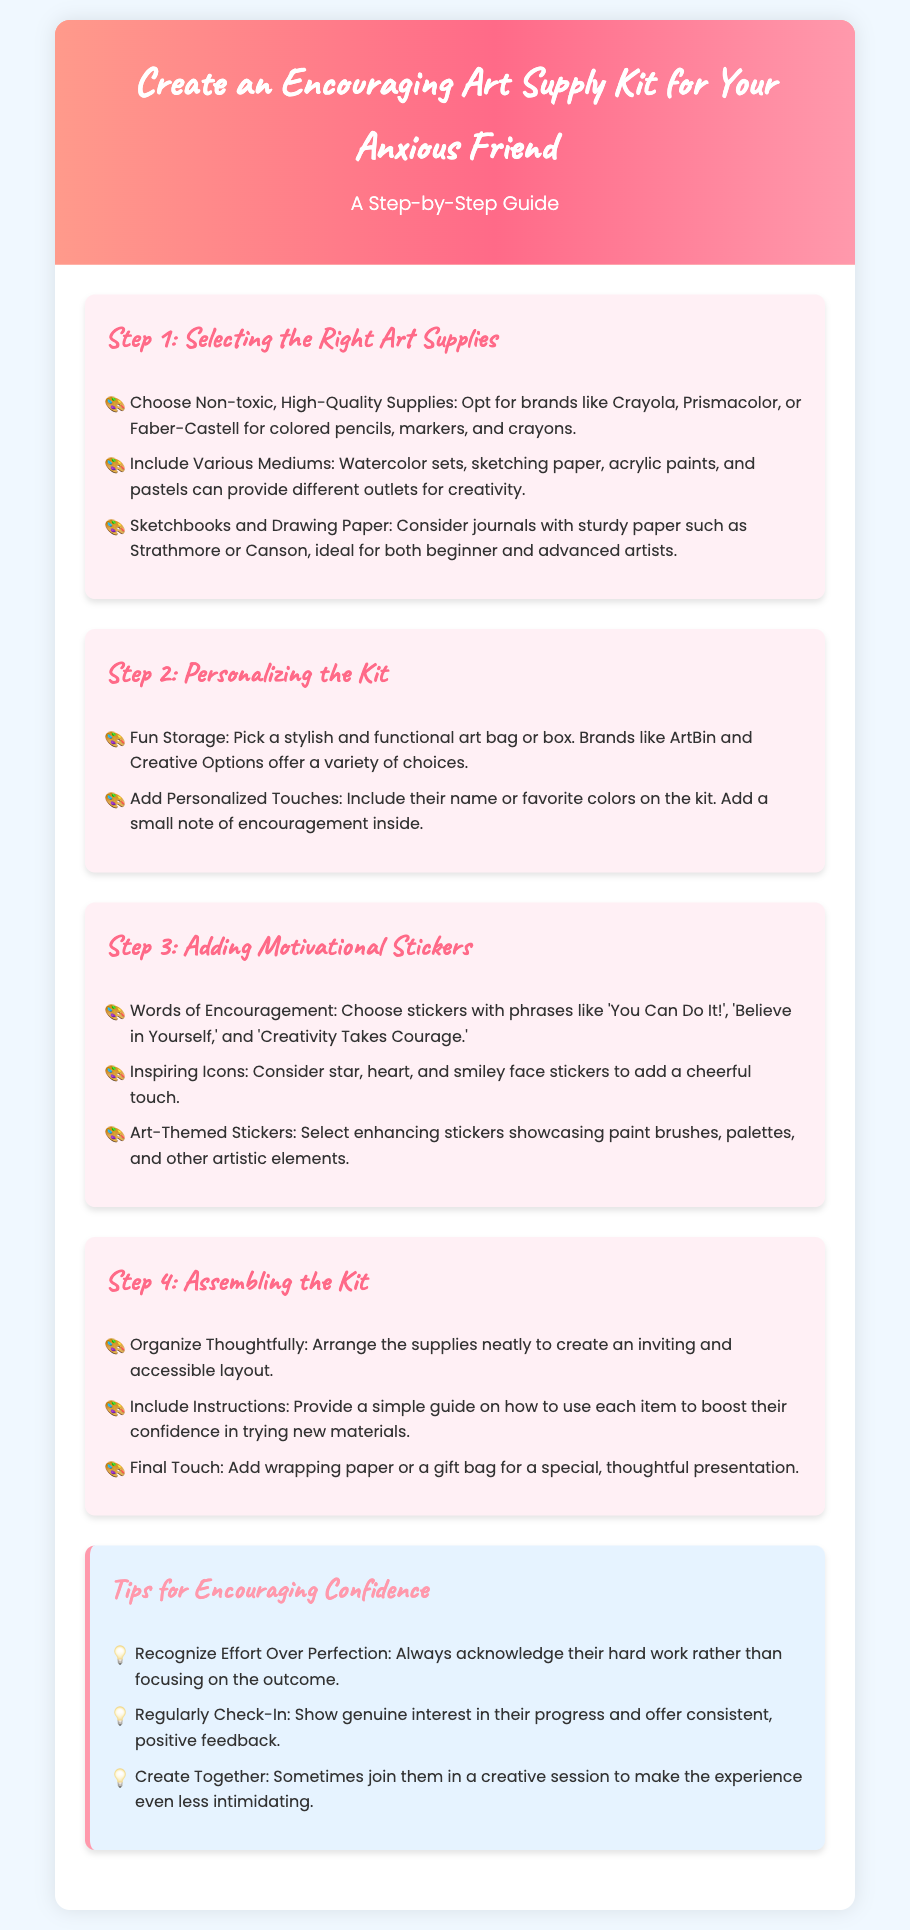What is the title of the document? The title is prominently displayed at the top of the document and reads "Create an Encouraging Art Supply Kit for Your Anxious Friend."
Answer: Create an Encouraging Art Supply Kit for Your Anxious Friend What is the first step in creating the art supply kit? The first step is described in the first section and states, "Selecting the Right Art Supplies."
Answer: Selecting the Right Art Supplies Which brand is suggested for colored pencils? The document lists brands in the first section, recommending specific names for colored pencils.
Answer: Prismacolor What is one type of sticker mentioned for encouragement? The third section mentions specific types of stickers designed to uplift the user.
Answer: 'You Can Do It!' How many steps are outlined in the document? The steps are listed sequentially in the document, and can be counted for a total number.
Answer: Four What is a suggested tip for building confidence? A variety of tips for encouraging confidence can be found in the tips section of the document.
Answer: Recognize Effort Over Perfection What color is the background of the header? The background color of the header can be determined by its description in the style section as well as the visual impression.
Answer: Gradient from #ff9a8b to #ff99ac What type of paper is recommended for sketching? This specific recommendation is provided under the first step section in the document where different types of paper are discussed.
Answer: Strathmore or Canson 